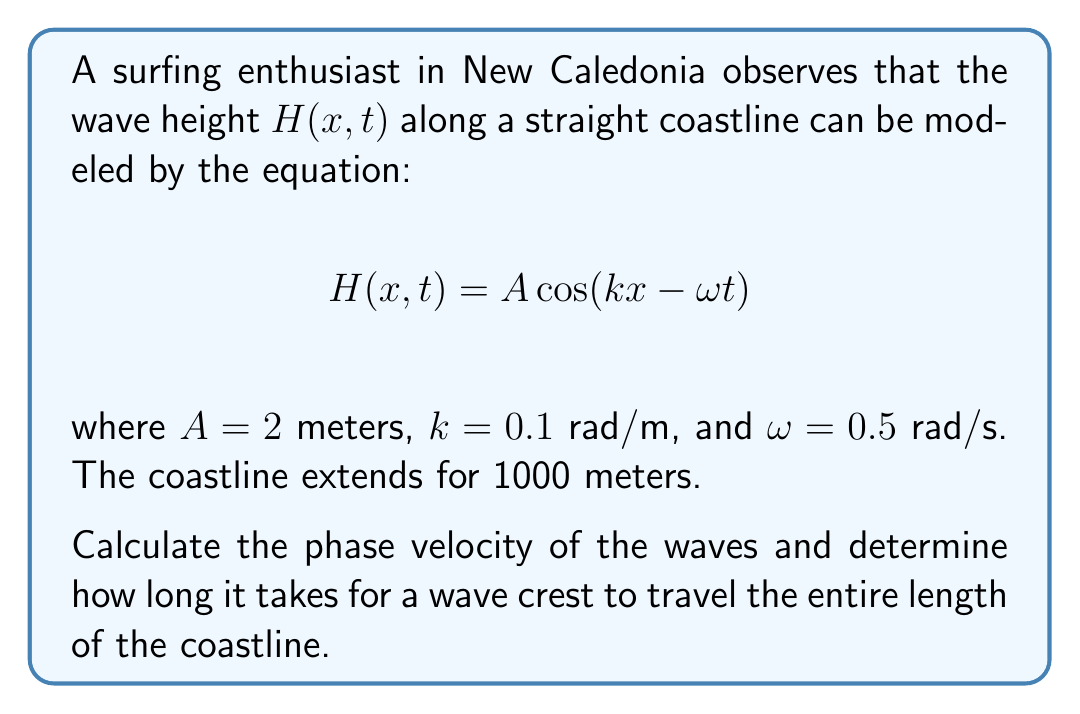Give your solution to this math problem. Let's approach this step-by-step:

1) The phase velocity $v_p$ of a wave is given by the formula:

   $$v_p = \frac{\omega}{k}$$

2) We're given that $\omega = 0.5$ rad/s and $k = 0.1$ rad/m. Let's substitute these values:

   $$v_p = \frac{0.5 \text{ rad/s}}{0.1 \text{ rad/m}} = 5 \text{ m/s}$$

3) Now that we know the phase velocity, we can calculate how long it takes for a wave crest to travel the entire coastline.

4) The coastline length is given as 1000 meters. We can use the basic formula:

   $$\text{Time} = \frac{\text{Distance}}{\text{Velocity}}$$

5) Substituting our values:

   $$\text{Time} = \frac{1000 \text{ m}}{5 \text{ m/s}} = 200 \text{ s}$$

Therefore, it takes 200 seconds (or 3 minutes and 20 seconds) for a wave crest to travel the entire length of the coastline.
Answer: Phase velocity: 5 m/s; Time to travel coastline: 200 s 